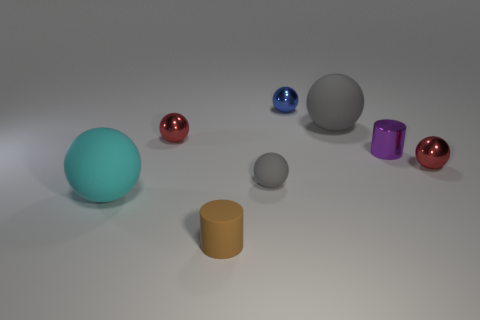Subtract 2 balls. How many balls are left? 4 Subtract all cyan balls. How many balls are left? 5 Subtract all red spheres. How many spheres are left? 4 Subtract all green balls. Subtract all brown blocks. How many balls are left? 6 Add 1 tiny metal objects. How many objects exist? 9 Subtract all cylinders. How many objects are left? 6 Subtract all purple cylinders. Subtract all purple metal things. How many objects are left? 6 Add 6 brown things. How many brown things are left? 7 Add 1 gray things. How many gray things exist? 3 Subtract 0 gray cylinders. How many objects are left? 8 